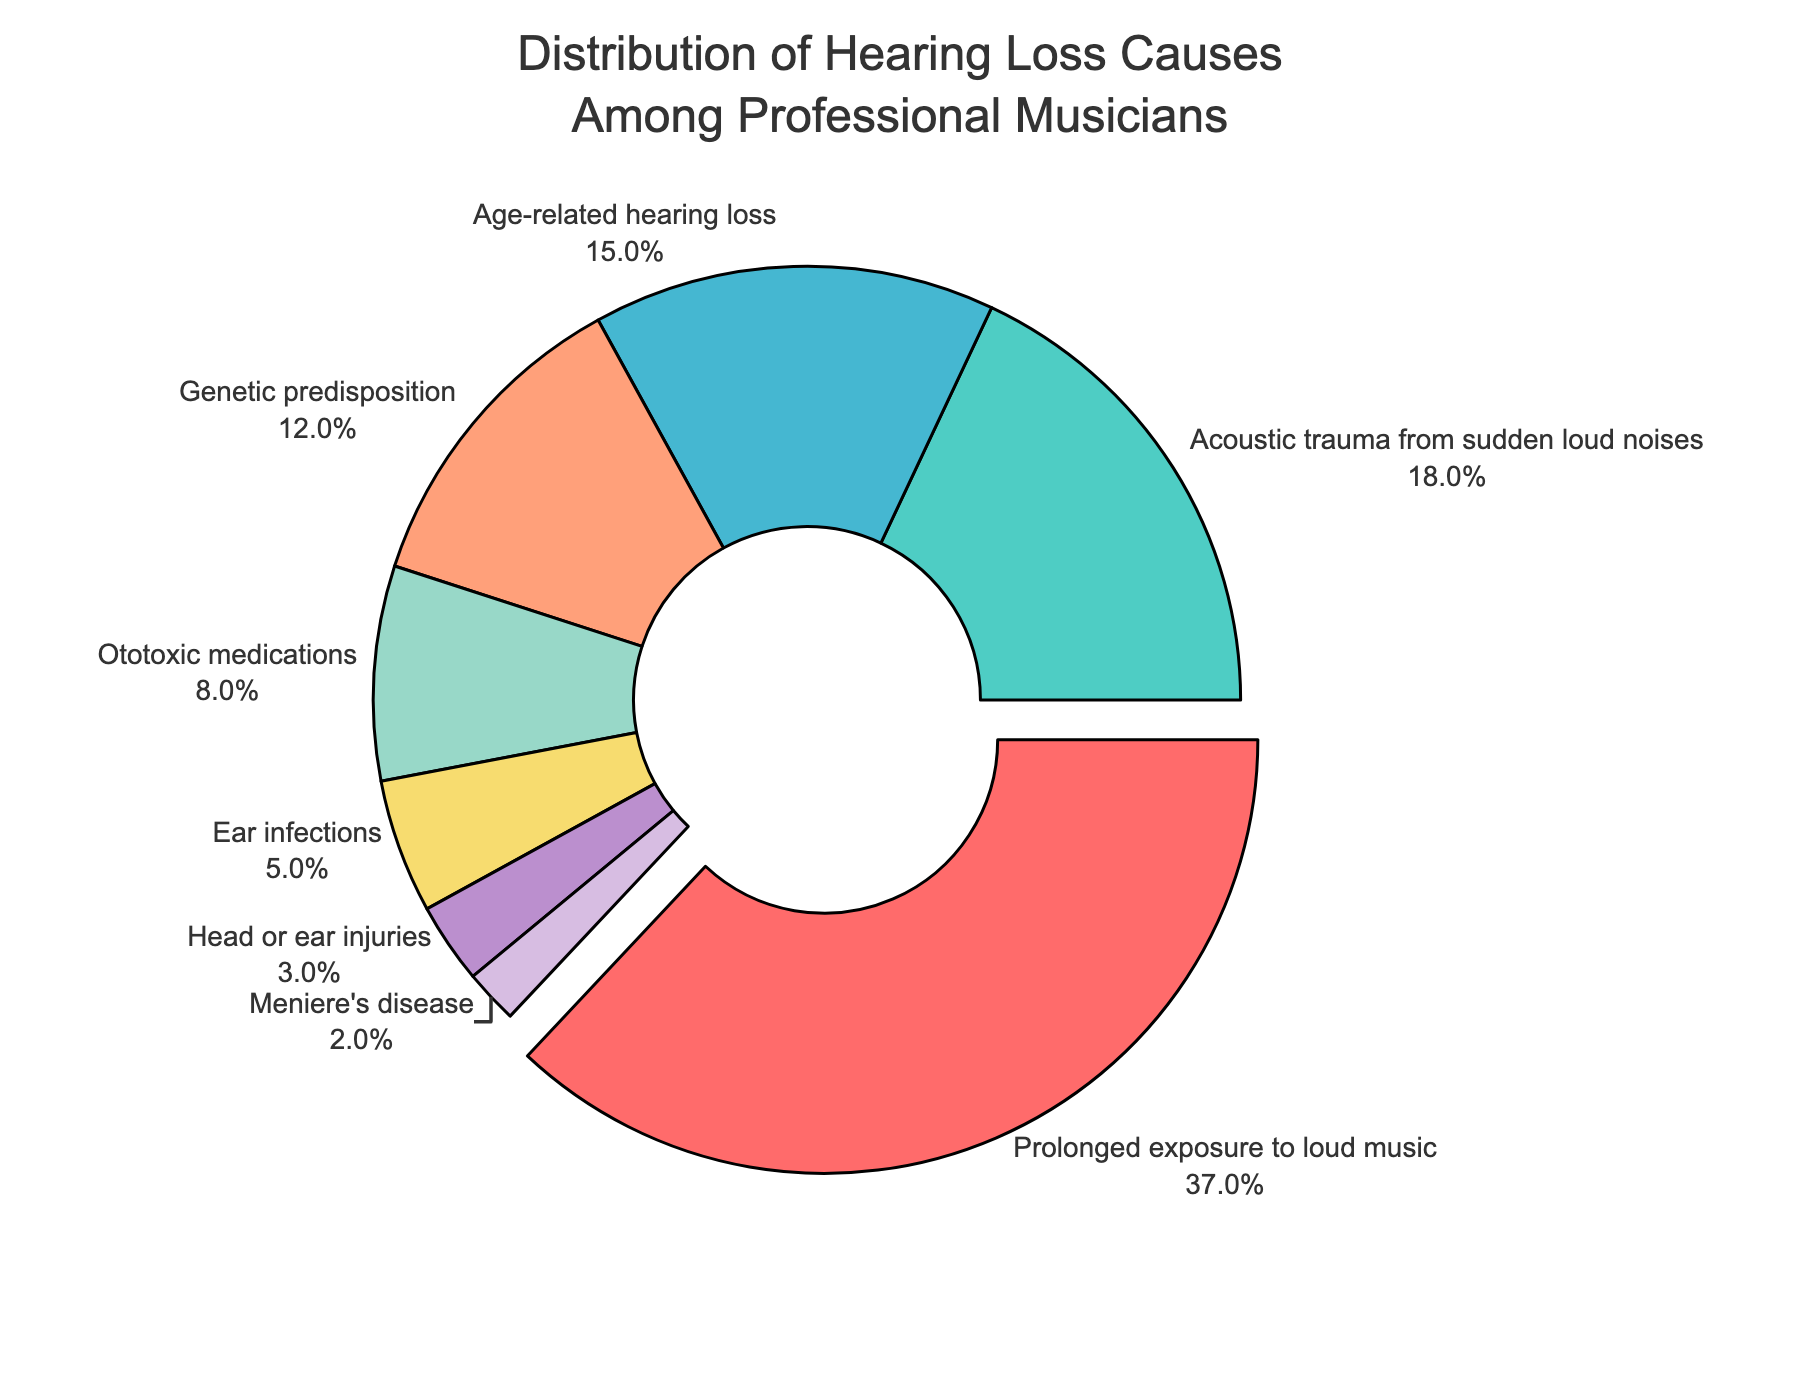What is the most common cause of hearing loss among professional musicians? The largest section of the pie chart is labeled "Prolonged exposure to loud music," with a percentage of 37%. This segment is also slightly pulled out for emphasis.
Answer: Prolonged exposure to loud music What percentage of hearing loss causes are attributed to genetic predisposition and ototoxic medications combined? Genetic predisposition is 12% and ototoxic medications are 8%. Adding these together gives 12 + 8 = 20%.
Answer: 20% How does the percentage for acoustic trauma from sudden loud noises compare to age-related hearing loss? The percentage for acoustic trauma from sudden loud noises is 18%, while age-related hearing loss is 15%. Since 18 is greater than 15, acoustic trauma has a higher percentage.
Answer: Acoustic trauma from sudden loud noises is higher What two causes have the smallest percentages, and what are those percentages? The two smallest sections of the pie chart are labeled "Head or ear injuries" and "Meniere's disease," with percentages of 3% and 2%, respectively.
Answer: Head or ear injuries (3%) and Meniere's disease (2%) Which cause of hearing loss has a percentage that is exactly one-third of the largest section? The largest section is 37% ("Prolonged exposure to loud music"). One-third of this value is approximately 12.33%. The closest section is "Genetic predisposition" with a percentage of 12%.
Answer: Genetic predisposition Among the listed causes, how many of them are associated with a percentage that is less than or equal to 5%? The causes are "Ear infections" (5%), "Head or ear injuries" (3%), and "Meniere's disease" (2%). Thus, there are three causes with percentages less than or equal to 5%.
Answer: 3 causes What is the average percentage of hearing loss attributed to age-related hearing loss, genetic predisposition, and ear infections? The percentages are 15% for age-related hearing loss, 12% for genetic predisposition, and 5% for ear infections. The average is calculated as (15+12+5) / 3 = 32 / 3 ≈ 10.67%.
Answer: 10.67% Compare the combined percentage of acoustic trauma and head or ear injuries to the percentage of age-related hearing loss. The combined percentage for acoustic trauma (18%) and head or ear injuries (3%) is 21%. Age-related hearing loss is 15%. Since 21 > 15, the combined percentage is higher.
Answer: Combined percentage is higher Which segments have a share that is less than half of the largest segment? The largest segment is 37%. Half of this is 18.5%. The segments with percentages less than 18.5% are: "Acoustic trauma from sudden loud noises" (18%), "Age-related hearing loss" (15%), "Genetic predisposition" (12%), "Ototoxic medications" (8%), "Ear infections" (5%), "Head or ear injuries" (3%), and "Meniere's disease" (2%).
Answer: All segments except 'Prolonged exposure to loud music.' Which cause of hearing loss has a percentage that is exactly three times that of Meniere's disease? Meniere's disease has a percentage of 2%. Three times this value is 6%. No segment precisely has a percentage of 6%; the closest higher value is "Ototoxic medications" at 8%, but this is not exact.
Answer: None 